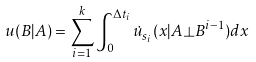Convert formula to latex. <formula><loc_0><loc_0><loc_500><loc_500>u ( B | A ) = \sum _ { i = 1 } ^ { k } \int _ { 0 } ^ { \Delta t _ { i } } \dot { u } _ { s _ { i } } ( x | A \bot B ^ { i - 1 } ) d x</formula> 